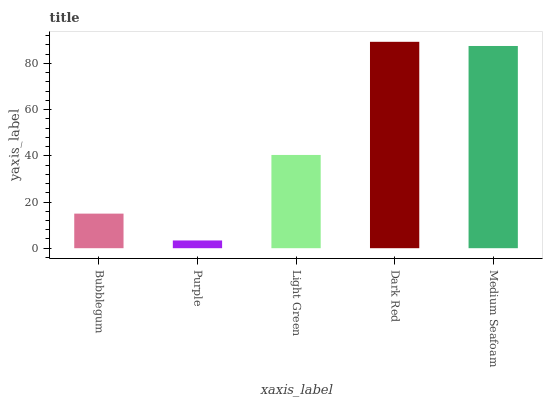Is Purple the minimum?
Answer yes or no. Yes. Is Dark Red the maximum?
Answer yes or no. Yes. Is Light Green the minimum?
Answer yes or no. No. Is Light Green the maximum?
Answer yes or no. No. Is Light Green greater than Purple?
Answer yes or no. Yes. Is Purple less than Light Green?
Answer yes or no. Yes. Is Purple greater than Light Green?
Answer yes or no. No. Is Light Green less than Purple?
Answer yes or no. No. Is Light Green the high median?
Answer yes or no. Yes. Is Light Green the low median?
Answer yes or no. Yes. Is Medium Seafoam the high median?
Answer yes or no. No. Is Purple the low median?
Answer yes or no. No. 